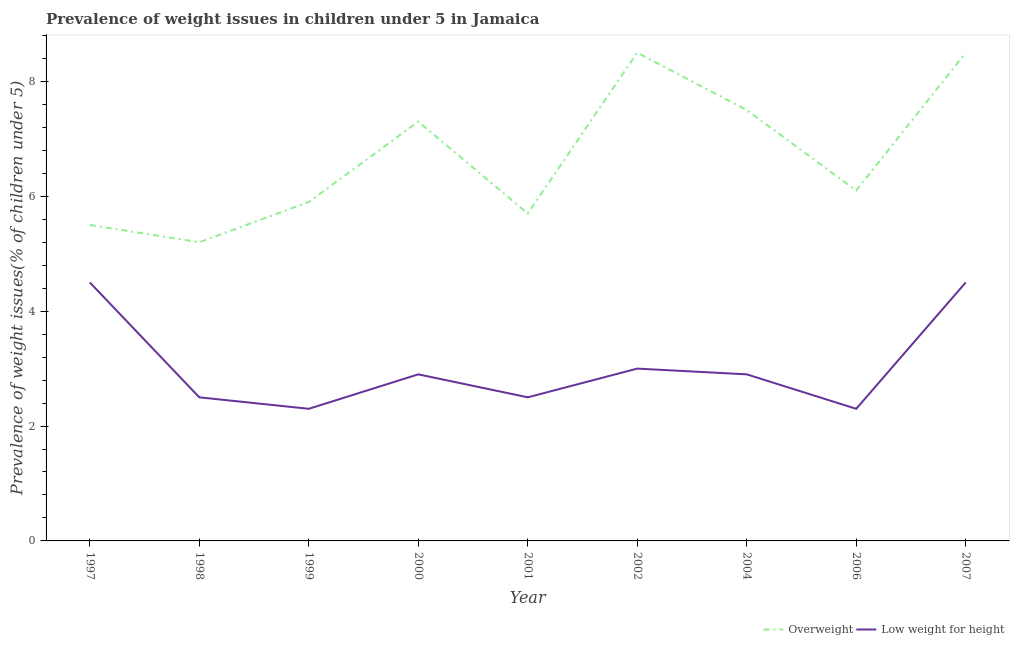Is the number of lines equal to the number of legend labels?
Provide a succinct answer. Yes. What is the percentage of overweight children in 1999?
Keep it short and to the point. 5.9. Across all years, what is the minimum percentage of underweight children?
Your response must be concise. 2.3. In which year was the percentage of overweight children maximum?
Your answer should be very brief. 2002. What is the total percentage of overweight children in the graph?
Provide a succinct answer. 60.2. What is the difference between the percentage of underweight children in 1999 and that in 2002?
Your answer should be very brief. -0.7. What is the difference between the percentage of underweight children in 2007 and the percentage of overweight children in 2000?
Offer a very short reply. -2.8. What is the average percentage of overweight children per year?
Ensure brevity in your answer.  6.69. In the year 2001, what is the difference between the percentage of overweight children and percentage of underweight children?
Make the answer very short. 3.2. What is the ratio of the percentage of underweight children in 2001 to that in 2002?
Offer a very short reply. 0.83. What is the difference between the highest and the lowest percentage of overweight children?
Give a very brief answer. 3.3. In how many years, is the percentage of underweight children greater than the average percentage of underweight children taken over all years?
Your response must be concise. 2. Is the percentage of underweight children strictly greater than the percentage of overweight children over the years?
Offer a terse response. No. Is the percentage of overweight children strictly less than the percentage of underweight children over the years?
Your response must be concise. No. How many lines are there?
Your response must be concise. 2. Does the graph contain any zero values?
Offer a terse response. No. Does the graph contain grids?
Your response must be concise. No. Where does the legend appear in the graph?
Give a very brief answer. Bottom right. How many legend labels are there?
Keep it short and to the point. 2. How are the legend labels stacked?
Your answer should be compact. Horizontal. What is the title of the graph?
Provide a succinct answer. Prevalence of weight issues in children under 5 in Jamaica. What is the label or title of the X-axis?
Your answer should be compact. Year. What is the label or title of the Y-axis?
Give a very brief answer. Prevalence of weight issues(% of children under 5). What is the Prevalence of weight issues(% of children under 5) of Overweight in 1997?
Your answer should be compact. 5.5. What is the Prevalence of weight issues(% of children under 5) of Overweight in 1998?
Keep it short and to the point. 5.2. What is the Prevalence of weight issues(% of children under 5) of Overweight in 1999?
Your answer should be compact. 5.9. What is the Prevalence of weight issues(% of children under 5) of Low weight for height in 1999?
Provide a short and direct response. 2.3. What is the Prevalence of weight issues(% of children under 5) in Overweight in 2000?
Provide a succinct answer. 7.3. What is the Prevalence of weight issues(% of children under 5) in Low weight for height in 2000?
Give a very brief answer. 2.9. What is the Prevalence of weight issues(% of children under 5) in Overweight in 2001?
Give a very brief answer. 5.7. What is the Prevalence of weight issues(% of children under 5) in Low weight for height in 2001?
Make the answer very short. 2.5. What is the Prevalence of weight issues(% of children under 5) in Overweight in 2002?
Keep it short and to the point. 8.5. What is the Prevalence of weight issues(% of children under 5) in Low weight for height in 2002?
Offer a very short reply. 3. What is the Prevalence of weight issues(% of children under 5) of Overweight in 2004?
Your response must be concise. 7.5. What is the Prevalence of weight issues(% of children under 5) of Low weight for height in 2004?
Give a very brief answer. 2.9. What is the Prevalence of weight issues(% of children under 5) of Overweight in 2006?
Provide a succinct answer. 6.1. What is the Prevalence of weight issues(% of children under 5) of Low weight for height in 2006?
Your answer should be very brief. 2.3. What is the Prevalence of weight issues(% of children under 5) in Low weight for height in 2007?
Provide a succinct answer. 4.5. Across all years, what is the minimum Prevalence of weight issues(% of children under 5) of Overweight?
Ensure brevity in your answer.  5.2. Across all years, what is the minimum Prevalence of weight issues(% of children under 5) of Low weight for height?
Make the answer very short. 2.3. What is the total Prevalence of weight issues(% of children under 5) of Overweight in the graph?
Offer a terse response. 60.2. What is the total Prevalence of weight issues(% of children under 5) of Low weight for height in the graph?
Your response must be concise. 27.4. What is the difference between the Prevalence of weight issues(% of children under 5) of Overweight in 1997 and that in 1998?
Provide a short and direct response. 0.3. What is the difference between the Prevalence of weight issues(% of children under 5) in Overweight in 1997 and that in 1999?
Give a very brief answer. -0.4. What is the difference between the Prevalence of weight issues(% of children under 5) of Overweight in 1997 and that in 2000?
Keep it short and to the point. -1.8. What is the difference between the Prevalence of weight issues(% of children under 5) of Overweight in 1997 and that in 2001?
Give a very brief answer. -0.2. What is the difference between the Prevalence of weight issues(% of children under 5) in Low weight for height in 1997 and that in 2001?
Ensure brevity in your answer.  2. What is the difference between the Prevalence of weight issues(% of children under 5) in Overweight in 1997 and that in 2004?
Keep it short and to the point. -2. What is the difference between the Prevalence of weight issues(% of children under 5) of Overweight in 1997 and that in 2006?
Offer a very short reply. -0.6. What is the difference between the Prevalence of weight issues(% of children under 5) in Low weight for height in 1997 and that in 2006?
Offer a very short reply. 2.2. What is the difference between the Prevalence of weight issues(% of children under 5) in Low weight for height in 1997 and that in 2007?
Give a very brief answer. 0. What is the difference between the Prevalence of weight issues(% of children under 5) in Overweight in 1998 and that in 2000?
Your answer should be very brief. -2.1. What is the difference between the Prevalence of weight issues(% of children under 5) of Overweight in 1998 and that in 2002?
Give a very brief answer. -3.3. What is the difference between the Prevalence of weight issues(% of children under 5) in Overweight in 1998 and that in 2004?
Your response must be concise. -2.3. What is the difference between the Prevalence of weight issues(% of children under 5) in Low weight for height in 1998 and that in 2006?
Your response must be concise. 0.2. What is the difference between the Prevalence of weight issues(% of children under 5) in Overweight in 1998 and that in 2007?
Give a very brief answer. -3.3. What is the difference between the Prevalence of weight issues(% of children under 5) of Low weight for height in 1998 and that in 2007?
Offer a terse response. -2. What is the difference between the Prevalence of weight issues(% of children under 5) in Overweight in 1999 and that in 2000?
Ensure brevity in your answer.  -1.4. What is the difference between the Prevalence of weight issues(% of children under 5) of Overweight in 1999 and that in 2002?
Ensure brevity in your answer.  -2.6. What is the difference between the Prevalence of weight issues(% of children under 5) in Low weight for height in 1999 and that in 2002?
Your answer should be compact. -0.7. What is the difference between the Prevalence of weight issues(% of children under 5) of Overweight in 1999 and that in 2004?
Offer a terse response. -1.6. What is the difference between the Prevalence of weight issues(% of children under 5) of Low weight for height in 1999 and that in 2004?
Ensure brevity in your answer.  -0.6. What is the difference between the Prevalence of weight issues(% of children under 5) of Overweight in 1999 and that in 2006?
Your response must be concise. -0.2. What is the difference between the Prevalence of weight issues(% of children under 5) in Overweight in 1999 and that in 2007?
Keep it short and to the point. -2.6. What is the difference between the Prevalence of weight issues(% of children under 5) in Low weight for height in 1999 and that in 2007?
Keep it short and to the point. -2.2. What is the difference between the Prevalence of weight issues(% of children under 5) of Low weight for height in 2000 and that in 2002?
Give a very brief answer. -0.1. What is the difference between the Prevalence of weight issues(% of children under 5) in Overweight in 2000 and that in 2006?
Ensure brevity in your answer.  1.2. What is the difference between the Prevalence of weight issues(% of children under 5) in Low weight for height in 2000 and that in 2006?
Keep it short and to the point. 0.6. What is the difference between the Prevalence of weight issues(% of children under 5) in Low weight for height in 2000 and that in 2007?
Your answer should be very brief. -1.6. What is the difference between the Prevalence of weight issues(% of children under 5) in Low weight for height in 2001 and that in 2002?
Make the answer very short. -0.5. What is the difference between the Prevalence of weight issues(% of children under 5) in Overweight in 2001 and that in 2004?
Make the answer very short. -1.8. What is the difference between the Prevalence of weight issues(% of children under 5) of Low weight for height in 2001 and that in 2004?
Provide a succinct answer. -0.4. What is the difference between the Prevalence of weight issues(% of children under 5) in Overweight in 2001 and that in 2006?
Keep it short and to the point. -0.4. What is the difference between the Prevalence of weight issues(% of children under 5) in Low weight for height in 2001 and that in 2006?
Keep it short and to the point. 0.2. What is the difference between the Prevalence of weight issues(% of children under 5) in Overweight in 2001 and that in 2007?
Offer a very short reply. -2.8. What is the difference between the Prevalence of weight issues(% of children under 5) in Low weight for height in 2001 and that in 2007?
Offer a very short reply. -2. What is the difference between the Prevalence of weight issues(% of children under 5) in Overweight in 2002 and that in 2004?
Provide a succinct answer. 1. What is the difference between the Prevalence of weight issues(% of children under 5) in Low weight for height in 2002 and that in 2006?
Offer a terse response. 0.7. What is the difference between the Prevalence of weight issues(% of children under 5) of Overweight in 2002 and that in 2007?
Ensure brevity in your answer.  0. What is the difference between the Prevalence of weight issues(% of children under 5) of Low weight for height in 2002 and that in 2007?
Keep it short and to the point. -1.5. What is the difference between the Prevalence of weight issues(% of children under 5) in Low weight for height in 2004 and that in 2007?
Your response must be concise. -1.6. What is the difference between the Prevalence of weight issues(% of children under 5) in Overweight in 2006 and that in 2007?
Make the answer very short. -2.4. What is the difference between the Prevalence of weight issues(% of children under 5) in Overweight in 1997 and the Prevalence of weight issues(% of children under 5) in Low weight for height in 1998?
Ensure brevity in your answer.  3. What is the difference between the Prevalence of weight issues(% of children under 5) in Overweight in 1997 and the Prevalence of weight issues(% of children under 5) in Low weight for height in 1999?
Your response must be concise. 3.2. What is the difference between the Prevalence of weight issues(% of children under 5) in Overweight in 1997 and the Prevalence of weight issues(% of children under 5) in Low weight for height in 2000?
Your answer should be very brief. 2.6. What is the difference between the Prevalence of weight issues(% of children under 5) in Overweight in 1997 and the Prevalence of weight issues(% of children under 5) in Low weight for height in 2001?
Give a very brief answer. 3. What is the difference between the Prevalence of weight issues(% of children under 5) of Overweight in 1997 and the Prevalence of weight issues(% of children under 5) of Low weight for height in 2002?
Offer a terse response. 2.5. What is the difference between the Prevalence of weight issues(% of children under 5) in Overweight in 1997 and the Prevalence of weight issues(% of children under 5) in Low weight for height in 2007?
Give a very brief answer. 1. What is the difference between the Prevalence of weight issues(% of children under 5) of Overweight in 1998 and the Prevalence of weight issues(% of children under 5) of Low weight for height in 1999?
Make the answer very short. 2.9. What is the difference between the Prevalence of weight issues(% of children under 5) of Overweight in 1998 and the Prevalence of weight issues(% of children under 5) of Low weight for height in 2000?
Make the answer very short. 2.3. What is the difference between the Prevalence of weight issues(% of children under 5) in Overweight in 1998 and the Prevalence of weight issues(% of children under 5) in Low weight for height in 2001?
Make the answer very short. 2.7. What is the difference between the Prevalence of weight issues(% of children under 5) of Overweight in 1998 and the Prevalence of weight issues(% of children under 5) of Low weight for height in 2002?
Your answer should be very brief. 2.2. What is the difference between the Prevalence of weight issues(% of children under 5) in Overweight in 1999 and the Prevalence of weight issues(% of children under 5) in Low weight for height in 2002?
Provide a short and direct response. 2.9. What is the difference between the Prevalence of weight issues(% of children under 5) in Overweight in 2000 and the Prevalence of weight issues(% of children under 5) in Low weight for height in 2001?
Offer a terse response. 4.8. What is the difference between the Prevalence of weight issues(% of children under 5) of Overweight in 2000 and the Prevalence of weight issues(% of children under 5) of Low weight for height in 2002?
Make the answer very short. 4.3. What is the difference between the Prevalence of weight issues(% of children under 5) in Overweight in 2000 and the Prevalence of weight issues(% of children under 5) in Low weight for height in 2006?
Make the answer very short. 5. What is the difference between the Prevalence of weight issues(% of children under 5) of Overweight in 2001 and the Prevalence of weight issues(% of children under 5) of Low weight for height in 2002?
Your answer should be compact. 2.7. What is the difference between the Prevalence of weight issues(% of children under 5) in Overweight in 2002 and the Prevalence of weight issues(% of children under 5) in Low weight for height in 2004?
Provide a succinct answer. 5.6. What is the difference between the Prevalence of weight issues(% of children under 5) of Overweight in 2002 and the Prevalence of weight issues(% of children under 5) of Low weight for height in 2006?
Keep it short and to the point. 6.2. What is the difference between the Prevalence of weight issues(% of children under 5) of Overweight in 2002 and the Prevalence of weight issues(% of children under 5) of Low weight for height in 2007?
Offer a very short reply. 4. What is the difference between the Prevalence of weight issues(% of children under 5) in Overweight in 2004 and the Prevalence of weight issues(% of children under 5) in Low weight for height in 2007?
Provide a short and direct response. 3. What is the average Prevalence of weight issues(% of children under 5) in Overweight per year?
Offer a very short reply. 6.69. What is the average Prevalence of weight issues(% of children under 5) in Low weight for height per year?
Your answer should be very brief. 3.04. In the year 1999, what is the difference between the Prevalence of weight issues(% of children under 5) of Overweight and Prevalence of weight issues(% of children under 5) of Low weight for height?
Give a very brief answer. 3.6. In the year 2001, what is the difference between the Prevalence of weight issues(% of children under 5) of Overweight and Prevalence of weight issues(% of children under 5) of Low weight for height?
Ensure brevity in your answer.  3.2. In the year 2002, what is the difference between the Prevalence of weight issues(% of children under 5) of Overweight and Prevalence of weight issues(% of children under 5) of Low weight for height?
Ensure brevity in your answer.  5.5. In the year 2006, what is the difference between the Prevalence of weight issues(% of children under 5) in Overweight and Prevalence of weight issues(% of children under 5) in Low weight for height?
Give a very brief answer. 3.8. What is the ratio of the Prevalence of weight issues(% of children under 5) of Overweight in 1997 to that in 1998?
Your response must be concise. 1.06. What is the ratio of the Prevalence of weight issues(% of children under 5) of Overweight in 1997 to that in 1999?
Your response must be concise. 0.93. What is the ratio of the Prevalence of weight issues(% of children under 5) in Low weight for height in 1997 to that in 1999?
Offer a very short reply. 1.96. What is the ratio of the Prevalence of weight issues(% of children under 5) of Overweight in 1997 to that in 2000?
Your answer should be very brief. 0.75. What is the ratio of the Prevalence of weight issues(% of children under 5) of Low weight for height in 1997 to that in 2000?
Offer a terse response. 1.55. What is the ratio of the Prevalence of weight issues(% of children under 5) in Overweight in 1997 to that in 2001?
Keep it short and to the point. 0.96. What is the ratio of the Prevalence of weight issues(% of children under 5) of Overweight in 1997 to that in 2002?
Your answer should be very brief. 0.65. What is the ratio of the Prevalence of weight issues(% of children under 5) in Overweight in 1997 to that in 2004?
Keep it short and to the point. 0.73. What is the ratio of the Prevalence of weight issues(% of children under 5) of Low weight for height in 1997 to that in 2004?
Your answer should be very brief. 1.55. What is the ratio of the Prevalence of weight issues(% of children under 5) in Overweight in 1997 to that in 2006?
Offer a terse response. 0.9. What is the ratio of the Prevalence of weight issues(% of children under 5) of Low weight for height in 1997 to that in 2006?
Give a very brief answer. 1.96. What is the ratio of the Prevalence of weight issues(% of children under 5) in Overweight in 1997 to that in 2007?
Provide a short and direct response. 0.65. What is the ratio of the Prevalence of weight issues(% of children under 5) in Low weight for height in 1997 to that in 2007?
Keep it short and to the point. 1. What is the ratio of the Prevalence of weight issues(% of children under 5) of Overweight in 1998 to that in 1999?
Your answer should be very brief. 0.88. What is the ratio of the Prevalence of weight issues(% of children under 5) of Low weight for height in 1998 to that in 1999?
Offer a terse response. 1.09. What is the ratio of the Prevalence of weight issues(% of children under 5) of Overweight in 1998 to that in 2000?
Make the answer very short. 0.71. What is the ratio of the Prevalence of weight issues(% of children under 5) of Low weight for height in 1998 to that in 2000?
Your response must be concise. 0.86. What is the ratio of the Prevalence of weight issues(% of children under 5) in Overweight in 1998 to that in 2001?
Provide a succinct answer. 0.91. What is the ratio of the Prevalence of weight issues(% of children under 5) in Overweight in 1998 to that in 2002?
Provide a succinct answer. 0.61. What is the ratio of the Prevalence of weight issues(% of children under 5) of Overweight in 1998 to that in 2004?
Give a very brief answer. 0.69. What is the ratio of the Prevalence of weight issues(% of children under 5) in Low weight for height in 1998 to that in 2004?
Your answer should be very brief. 0.86. What is the ratio of the Prevalence of weight issues(% of children under 5) in Overweight in 1998 to that in 2006?
Keep it short and to the point. 0.85. What is the ratio of the Prevalence of weight issues(% of children under 5) of Low weight for height in 1998 to that in 2006?
Give a very brief answer. 1.09. What is the ratio of the Prevalence of weight issues(% of children under 5) in Overweight in 1998 to that in 2007?
Provide a succinct answer. 0.61. What is the ratio of the Prevalence of weight issues(% of children under 5) in Low weight for height in 1998 to that in 2007?
Provide a succinct answer. 0.56. What is the ratio of the Prevalence of weight issues(% of children under 5) of Overweight in 1999 to that in 2000?
Ensure brevity in your answer.  0.81. What is the ratio of the Prevalence of weight issues(% of children under 5) of Low weight for height in 1999 to that in 2000?
Provide a succinct answer. 0.79. What is the ratio of the Prevalence of weight issues(% of children under 5) in Overweight in 1999 to that in 2001?
Make the answer very short. 1.04. What is the ratio of the Prevalence of weight issues(% of children under 5) in Low weight for height in 1999 to that in 2001?
Offer a terse response. 0.92. What is the ratio of the Prevalence of weight issues(% of children under 5) in Overweight in 1999 to that in 2002?
Provide a short and direct response. 0.69. What is the ratio of the Prevalence of weight issues(% of children under 5) of Low weight for height in 1999 to that in 2002?
Provide a short and direct response. 0.77. What is the ratio of the Prevalence of weight issues(% of children under 5) in Overweight in 1999 to that in 2004?
Keep it short and to the point. 0.79. What is the ratio of the Prevalence of weight issues(% of children under 5) in Low weight for height in 1999 to that in 2004?
Ensure brevity in your answer.  0.79. What is the ratio of the Prevalence of weight issues(% of children under 5) in Overweight in 1999 to that in 2006?
Make the answer very short. 0.97. What is the ratio of the Prevalence of weight issues(% of children under 5) in Low weight for height in 1999 to that in 2006?
Your answer should be compact. 1. What is the ratio of the Prevalence of weight issues(% of children under 5) in Overweight in 1999 to that in 2007?
Give a very brief answer. 0.69. What is the ratio of the Prevalence of weight issues(% of children under 5) of Low weight for height in 1999 to that in 2007?
Make the answer very short. 0.51. What is the ratio of the Prevalence of weight issues(% of children under 5) in Overweight in 2000 to that in 2001?
Keep it short and to the point. 1.28. What is the ratio of the Prevalence of weight issues(% of children under 5) in Low weight for height in 2000 to that in 2001?
Ensure brevity in your answer.  1.16. What is the ratio of the Prevalence of weight issues(% of children under 5) in Overweight in 2000 to that in 2002?
Ensure brevity in your answer.  0.86. What is the ratio of the Prevalence of weight issues(% of children under 5) in Low weight for height in 2000 to that in 2002?
Give a very brief answer. 0.97. What is the ratio of the Prevalence of weight issues(% of children under 5) in Overweight in 2000 to that in 2004?
Give a very brief answer. 0.97. What is the ratio of the Prevalence of weight issues(% of children under 5) of Overweight in 2000 to that in 2006?
Offer a terse response. 1.2. What is the ratio of the Prevalence of weight issues(% of children under 5) in Low weight for height in 2000 to that in 2006?
Your response must be concise. 1.26. What is the ratio of the Prevalence of weight issues(% of children under 5) of Overweight in 2000 to that in 2007?
Provide a short and direct response. 0.86. What is the ratio of the Prevalence of weight issues(% of children under 5) in Low weight for height in 2000 to that in 2007?
Ensure brevity in your answer.  0.64. What is the ratio of the Prevalence of weight issues(% of children under 5) in Overweight in 2001 to that in 2002?
Give a very brief answer. 0.67. What is the ratio of the Prevalence of weight issues(% of children under 5) in Low weight for height in 2001 to that in 2002?
Provide a succinct answer. 0.83. What is the ratio of the Prevalence of weight issues(% of children under 5) in Overweight in 2001 to that in 2004?
Give a very brief answer. 0.76. What is the ratio of the Prevalence of weight issues(% of children under 5) in Low weight for height in 2001 to that in 2004?
Your answer should be very brief. 0.86. What is the ratio of the Prevalence of weight issues(% of children under 5) in Overweight in 2001 to that in 2006?
Keep it short and to the point. 0.93. What is the ratio of the Prevalence of weight issues(% of children under 5) of Low weight for height in 2001 to that in 2006?
Offer a very short reply. 1.09. What is the ratio of the Prevalence of weight issues(% of children under 5) of Overweight in 2001 to that in 2007?
Keep it short and to the point. 0.67. What is the ratio of the Prevalence of weight issues(% of children under 5) in Low weight for height in 2001 to that in 2007?
Provide a succinct answer. 0.56. What is the ratio of the Prevalence of weight issues(% of children under 5) in Overweight in 2002 to that in 2004?
Provide a succinct answer. 1.13. What is the ratio of the Prevalence of weight issues(% of children under 5) of Low weight for height in 2002 to that in 2004?
Your answer should be very brief. 1.03. What is the ratio of the Prevalence of weight issues(% of children under 5) of Overweight in 2002 to that in 2006?
Your response must be concise. 1.39. What is the ratio of the Prevalence of weight issues(% of children under 5) of Low weight for height in 2002 to that in 2006?
Ensure brevity in your answer.  1.3. What is the ratio of the Prevalence of weight issues(% of children under 5) of Overweight in 2002 to that in 2007?
Provide a short and direct response. 1. What is the ratio of the Prevalence of weight issues(% of children under 5) in Low weight for height in 2002 to that in 2007?
Your response must be concise. 0.67. What is the ratio of the Prevalence of weight issues(% of children under 5) of Overweight in 2004 to that in 2006?
Your answer should be compact. 1.23. What is the ratio of the Prevalence of weight issues(% of children under 5) in Low weight for height in 2004 to that in 2006?
Provide a short and direct response. 1.26. What is the ratio of the Prevalence of weight issues(% of children under 5) of Overweight in 2004 to that in 2007?
Ensure brevity in your answer.  0.88. What is the ratio of the Prevalence of weight issues(% of children under 5) of Low weight for height in 2004 to that in 2007?
Offer a very short reply. 0.64. What is the ratio of the Prevalence of weight issues(% of children under 5) in Overweight in 2006 to that in 2007?
Offer a very short reply. 0.72. What is the ratio of the Prevalence of weight issues(% of children under 5) of Low weight for height in 2006 to that in 2007?
Your answer should be compact. 0.51. What is the difference between the highest and the second highest Prevalence of weight issues(% of children under 5) in Overweight?
Keep it short and to the point. 0. 